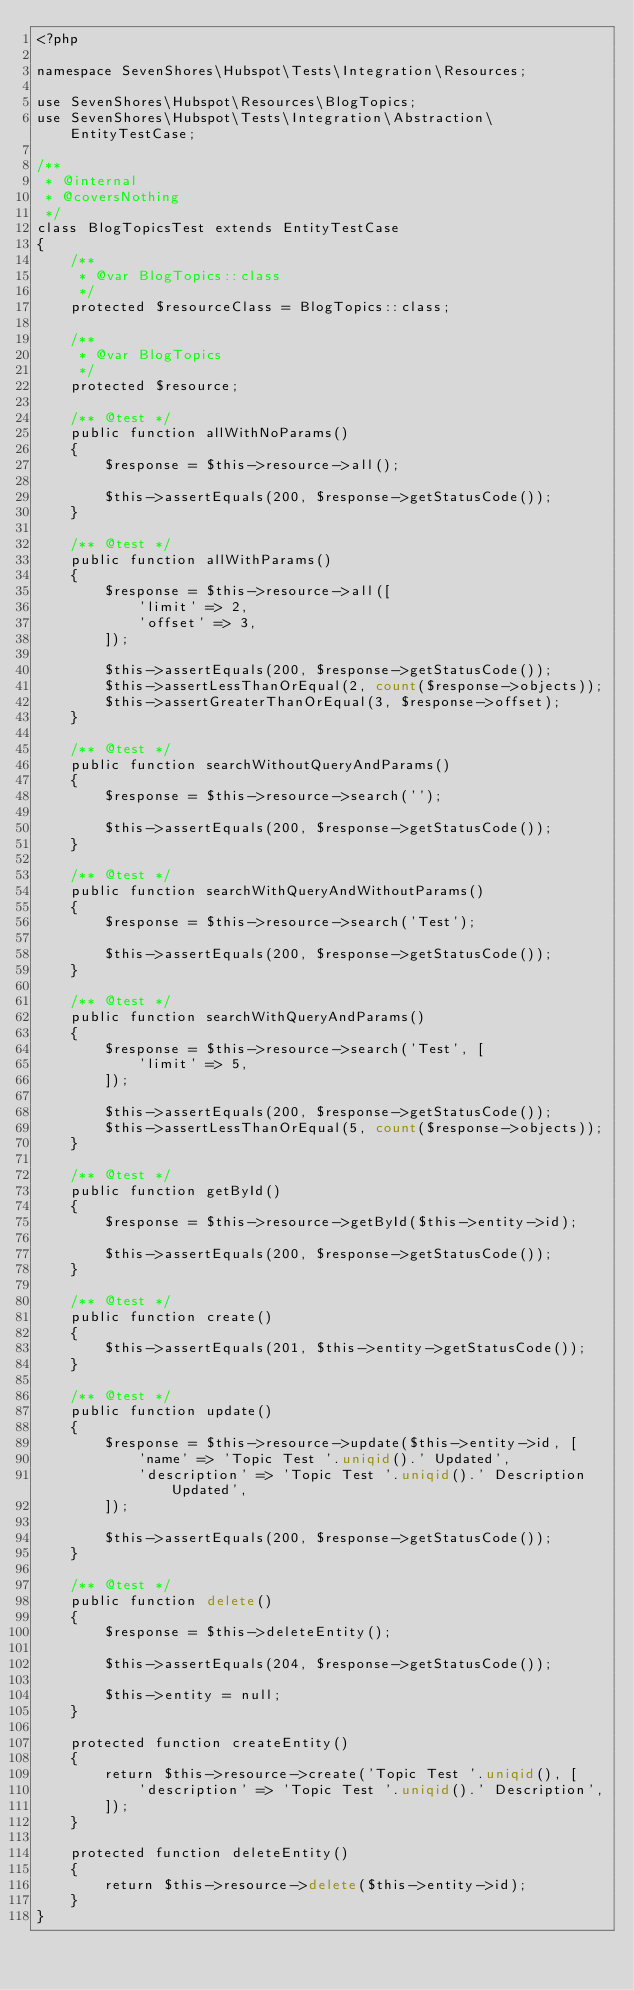Convert code to text. <code><loc_0><loc_0><loc_500><loc_500><_PHP_><?php

namespace SevenShores\Hubspot\Tests\Integration\Resources;

use SevenShores\Hubspot\Resources\BlogTopics;
use SevenShores\Hubspot\Tests\Integration\Abstraction\EntityTestCase;

/**
 * @internal
 * @coversNothing
 */
class BlogTopicsTest extends EntityTestCase
{
    /**
     * @var BlogTopics::class
     */
    protected $resourceClass = BlogTopics::class;

    /**
     * @var BlogTopics
     */
    protected $resource;

    /** @test */
    public function allWithNoParams()
    {
        $response = $this->resource->all();

        $this->assertEquals(200, $response->getStatusCode());
    }

    /** @test */
    public function allWithParams()
    {
        $response = $this->resource->all([
            'limit' => 2,
            'offset' => 3,
        ]);

        $this->assertEquals(200, $response->getStatusCode());
        $this->assertLessThanOrEqual(2, count($response->objects));
        $this->assertGreaterThanOrEqual(3, $response->offset);
    }

    /** @test */
    public function searchWithoutQueryAndParams()
    {
        $response = $this->resource->search('');

        $this->assertEquals(200, $response->getStatusCode());
    }

    /** @test */
    public function searchWithQueryAndWithoutParams()
    {
        $response = $this->resource->search('Test');

        $this->assertEquals(200, $response->getStatusCode());
    }

    /** @test */
    public function searchWithQueryAndParams()
    {
        $response = $this->resource->search('Test', [
            'limit' => 5,
        ]);

        $this->assertEquals(200, $response->getStatusCode());
        $this->assertLessThanOrEqual(5, count($response->objects));
    }

    /** @test */
    public function getById()
    {
        $response = $this->resource->getById($this->entity->id);

        $this->assertEquals(200, $response->getStatusCode());
    }

    /** @test */
    public function create()
    {
        $this->assertEquals(201, $this->entity->getStatusCode());
    }

    /** @test */
    public function update()
    {
        $response = $this->resource->update($this->entity->id, [
            'name' => 'Topic Test '.uniqid().' Updated',
            'description' => 'Topic Test '.uniqid().' Description Updated',
        ]);

        $this->assertEquals(200, $response->getStatusCode());
    }

    /** @test */
    public function delete()
    {
        $response = $this->deleteEntity();

        $this->assertEquals(204, $response->getStatusCode());

        $this->entity = null;
    }

    protected function createEntity()
    {
        return $this->resource->create('Topic Test '.uniqid(), [
            'description' => 'Topic Test '.uniqid().' Description',
        ]);
    }

    protected function deleteEntity()
    {
        return $this->resource->delete($this->entity->id);
    }
}
</code> 